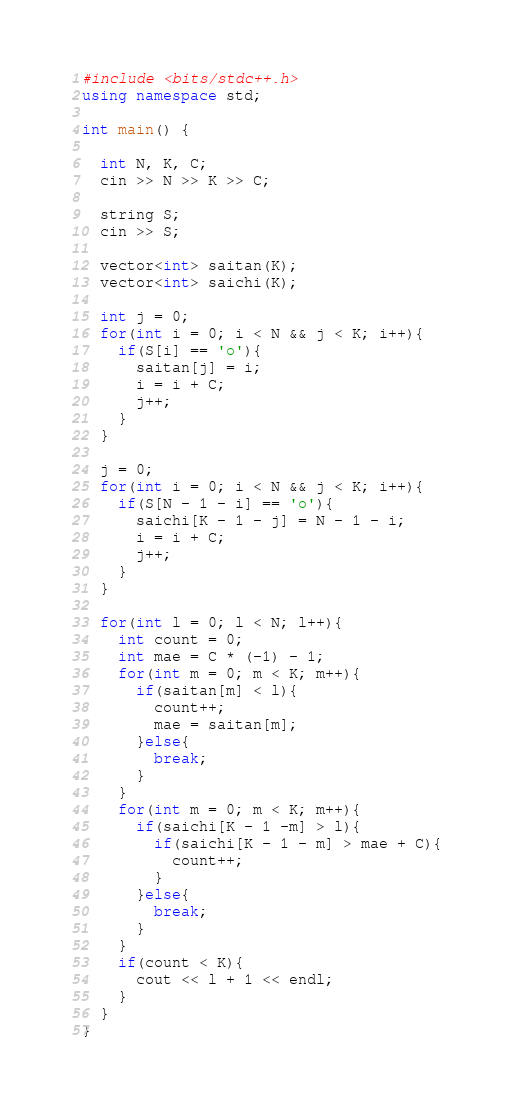<code> <loc_0><loc_0><loc_500><loc_500><_C++_>#include <bits/stdc++.h>
using namespace std;

int main() {

  int N, K, C;
  cin >> N >> K >> C;

  string S;
  cin >> S;

  vector<int> saitan(K);
  vector<int> saichi(K);

  int j = 0;
  for(int i = 0; i < N && j < K; i++){
    if(S[i] == 'o'){
      saitan[j] = i;
      i = i + C;
      j++;
    }
  }

  j = 0;
  for(int i = 0; i < N && j < K; i++){
    if(S[N - 1 - i] == 'o'){
      saichi[K - 1 - j] = N - 1 - i;
      i = i + C;
      j++;
    }
  }

  for(int l = 0; l < N; l++){
    int count = 0;
    int mae = C * (-1) - 1;
    for(int m = 0; m < K; m++){
      if(saitan[m] < l){
        count++;
        mae = saitan[m];
      }else{
        break;
      }
    }
    for(int m = 0; m < K; m++){
      if(saichi[K - 1 -m] > l){
        if(saichi[K - 1 - m] > mae + C){
          count++;
        }
      }else{
        break;
      }
    }
    if(count < K){
      cout << l + 1 << endl;
    }
  }
}</code> 